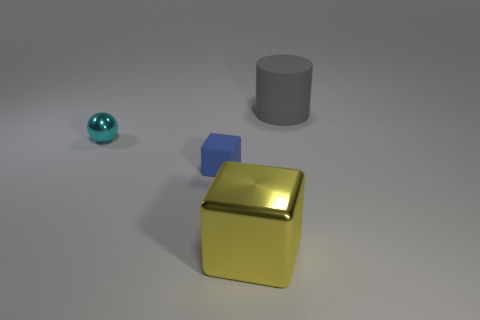What might be the relative positions of the objects in terms of depth? The blue ball appears closest to the viewer, with the yellow block positioned further back in the midground, and the gray cylinder looks to be the farthest in the scene, creating an interesting spatial arrangement. 